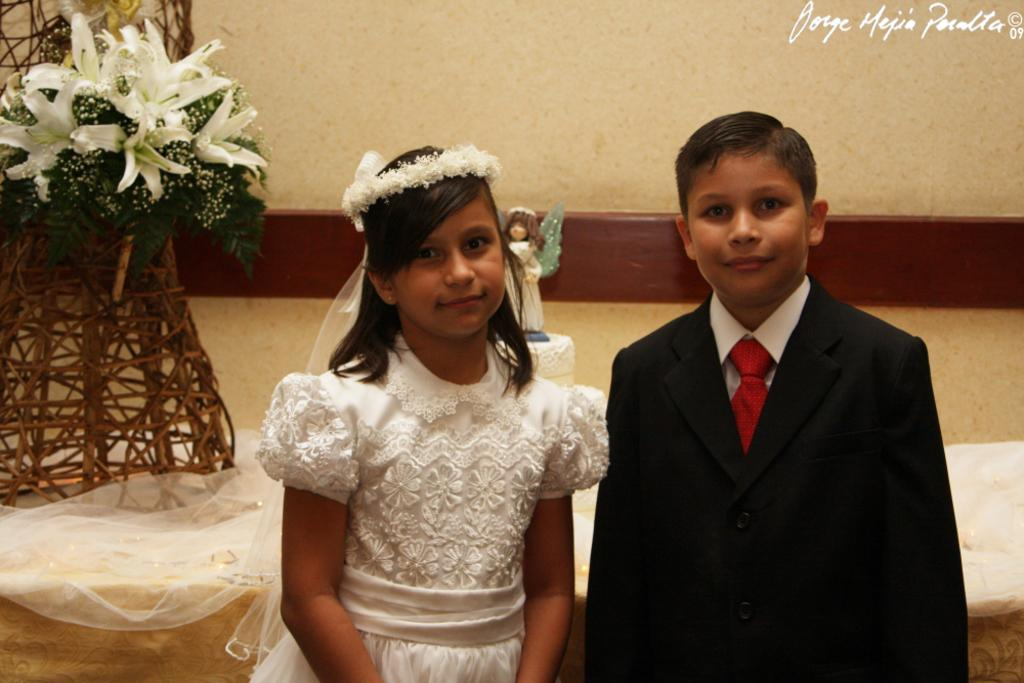Who are the people in the image? There is a girl and a boy in the image. What can be seen in the background of the image? There is decor and walls visible in the image. What type of cushion is being used by the cart in the image? There is no cushion or cart present in the image. What is the needle being used for in the image? There is no needle present in the image. 